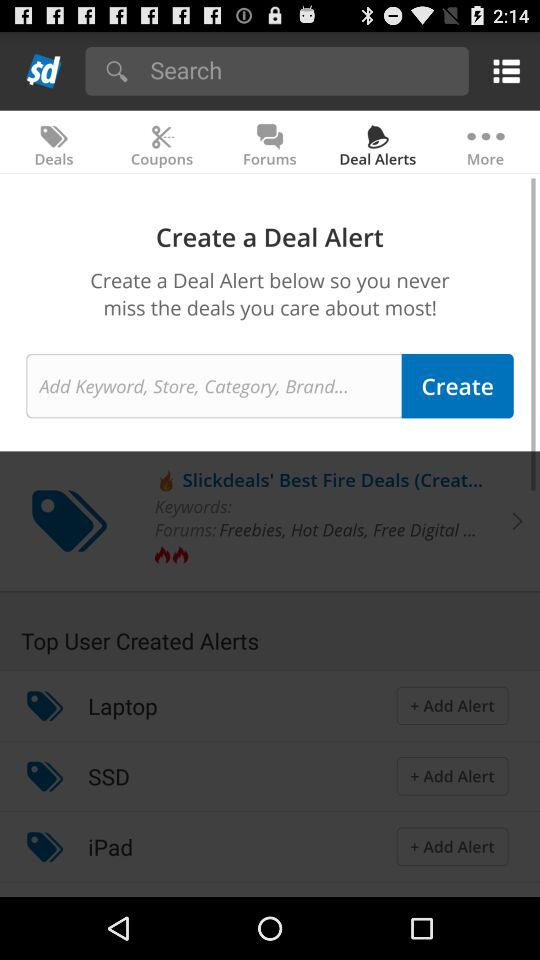Which tab are we currently on? You are currently on the "Deal Alerts" tab. 